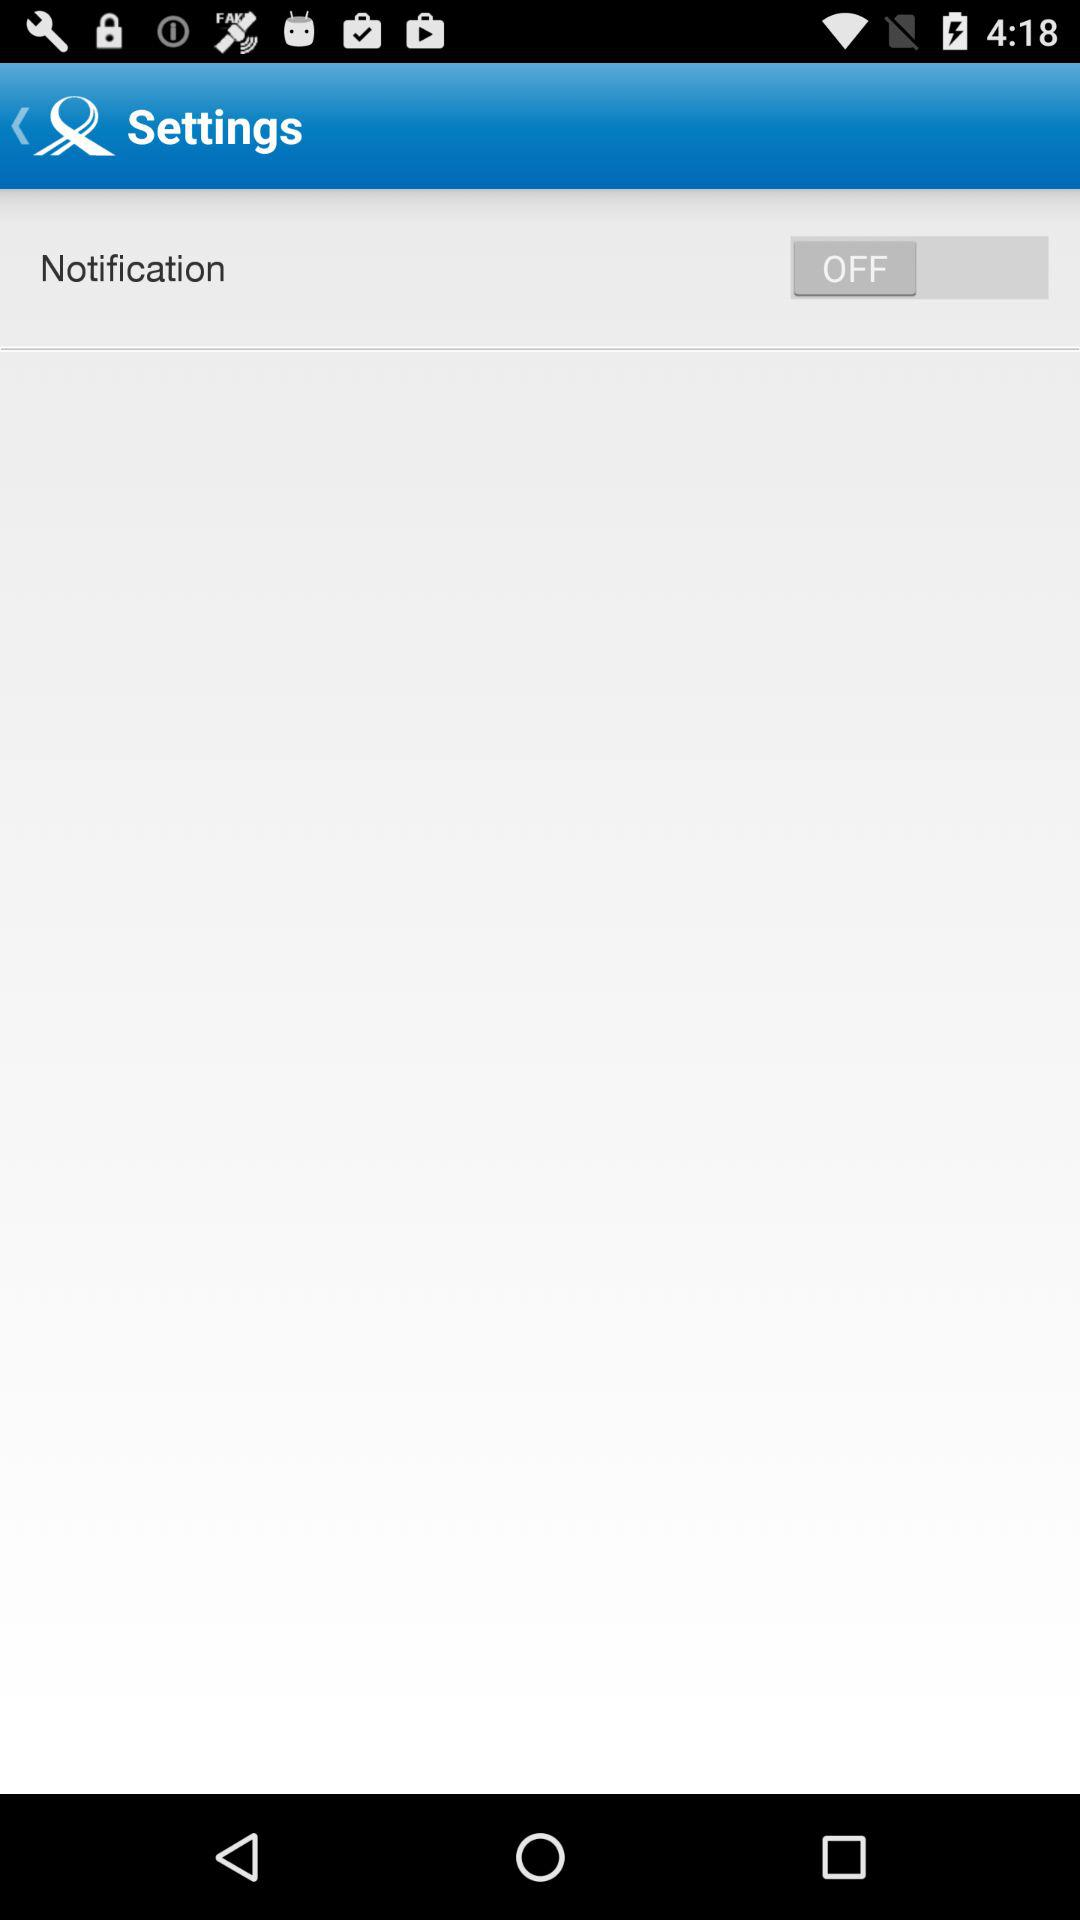What is the status of the "Notification"? The status is "off". 